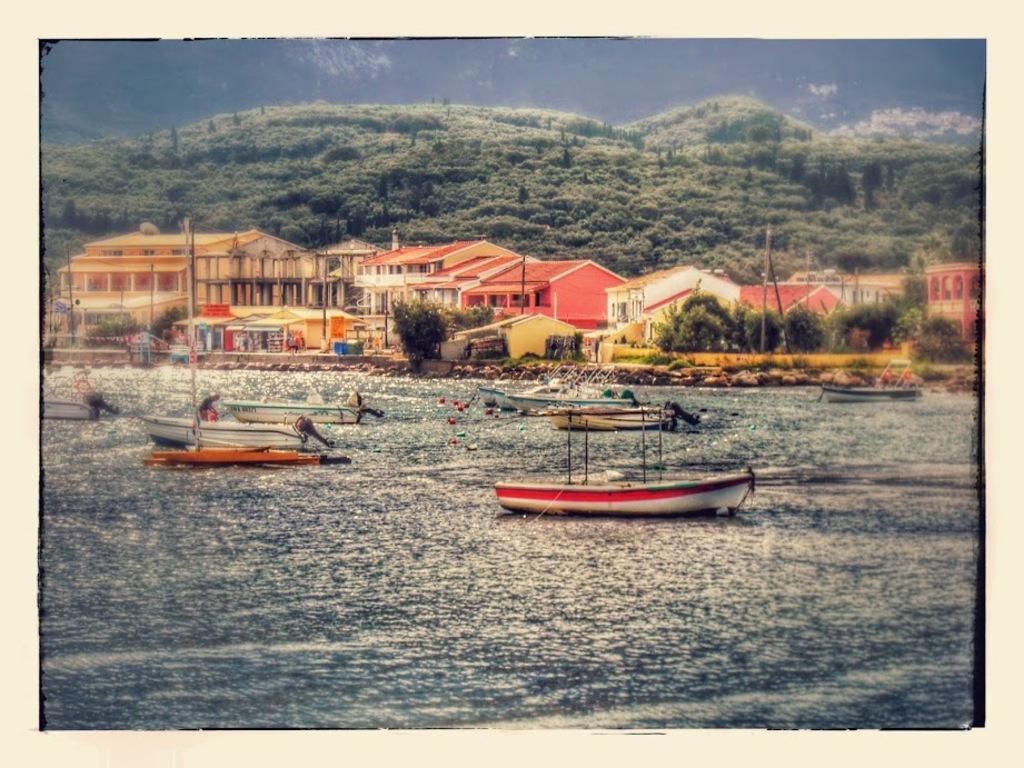Please provide a concise description of this image. Here, we can see a picture, in that picture there is water and there are some boats and we can see some buildings, there are some trees, at the top there is a sky. 